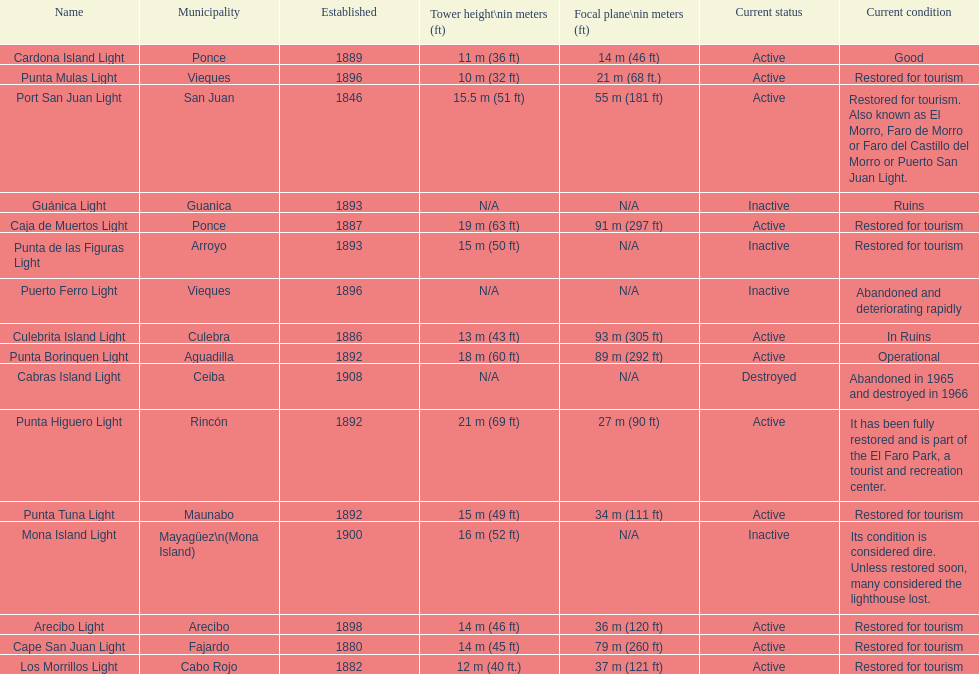Were any towers established before the year 1800? No. 